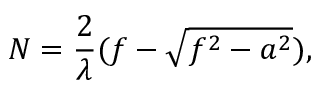<formula> <loc_0><loc_0><loc_500><loc_500>N = \frac { 2 } { \lambda } ( f - \sqrt { f ^ { 2 } - a ^ { 2 } } ) ,</formula> 